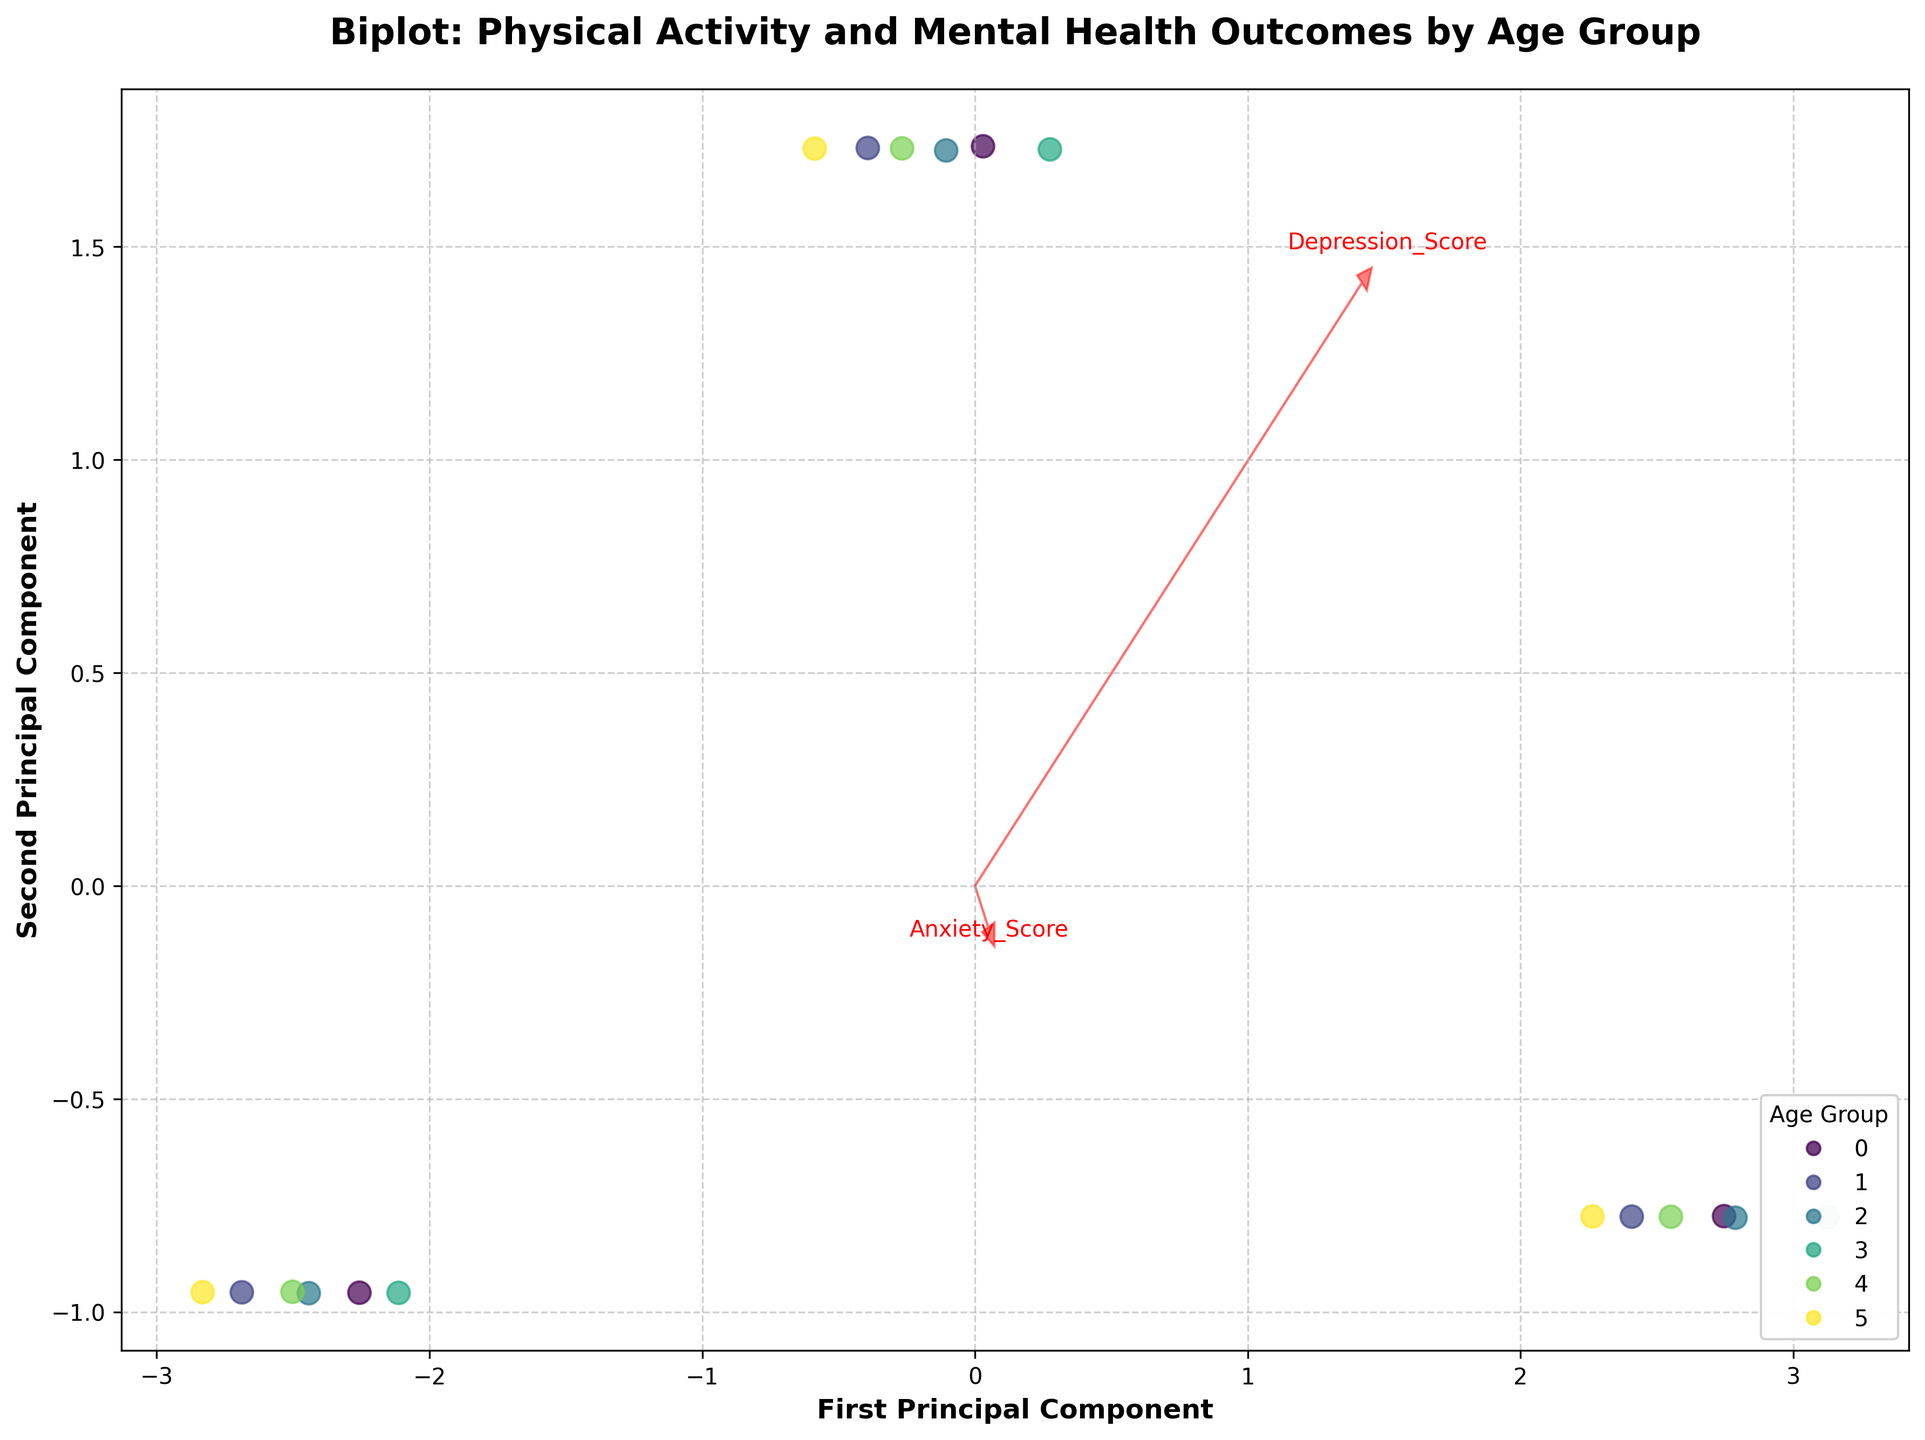What is the title of the figure? The title is typically displayed at the top of the figure. In this case, the title is "Biplot: Physical Activity and Mental Health Outcomes by Age Group."
Answer: Biplot: Physical Activity and Mental Health Outcomes by Age Group How many principal components are displayed on the axes? The axes are labeled with the names of the principal components. Here, the labels are "First Principal Component" and "Second Principal Component," indicating that two principal components are displayed.
Answer: Two What color scheme is used to represent different age groups? The legend in the bottom right corner indicates that a color scheme is used to represent different age groups, and the color palette seems to be 'viridis' based on different shades ranging from dark to light.
Answer: 'Viridis' color scheme What do the red arrows represent? The red arrows are typically used to represent the feature vectors in a biplot, showing the direction and importance of each original variable.
Answer: Feature vectors of original variables Which age group has the most data points at the bottom right of the plot? By observing the scatter plot in the bottom right region and matching the colors to the legend, the data points with higher principal component 1 and lower principal component 2 are mostly represented by the color corresponding to the 25-34 age group.
Answer: 25-34 age group Which variable has the largest arrow and what does this imply? By examining the red arrows, "Depression_Score" has the longest arrow, implying it has the highest loading and contributes most significantly to the variation captured by the principal components.
Answer: Depression_Score Compare the position of the "Life_Satisfaction" arrow to the "Anxiety_Score" arrow. What does this suggest about their relationship in the data? The "Life_Satisfaction" arrow points in almost the opposite direction to the "Anxiety_Score" arrow, suggesting a negative relationship between life satisfaction and anxiety scores among the data points.
Answer: Negative relationship Which age group appears to have the highest physical activity levels, based on the clustering of data points? The cluster of data points in the top left region, mostly in light green and yellow, indicates higher principal component 1 and component 2, aligning with higher levels of physical activity. This color corresponds to the 65+ age group.
Answer: 65+ age group Do mental health outcomes (Depression/Anxiety) seem better or worse for groups with higher physical activity levels? By inspecting the clustering around the arrows representing high physical activity levels, it appears those groups have lower depression and anxiety scores, indicating better mental health outcomes for higher physical activity levels.
Answer: Better 